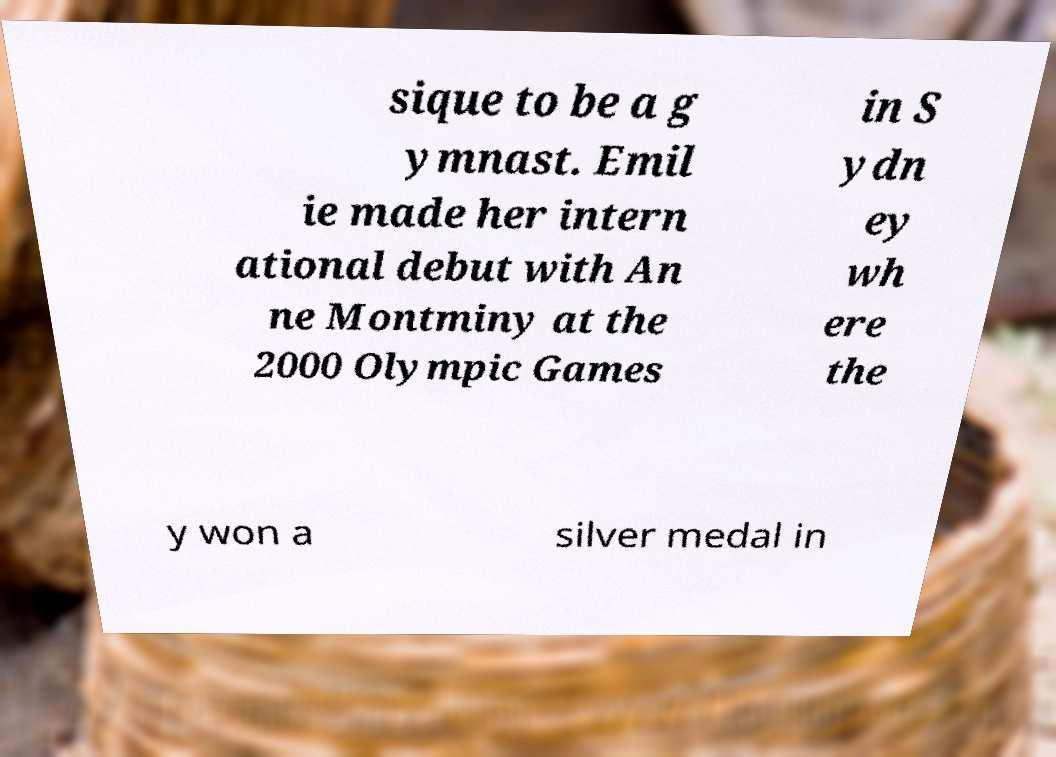Could you extract and type out the text from this image? sique to be a g ymnast. Emil ie made her intern ational debut with An ne Montminy at the 2000 Olympic Games in S ydn ey wh ere the y won a silver medal in 